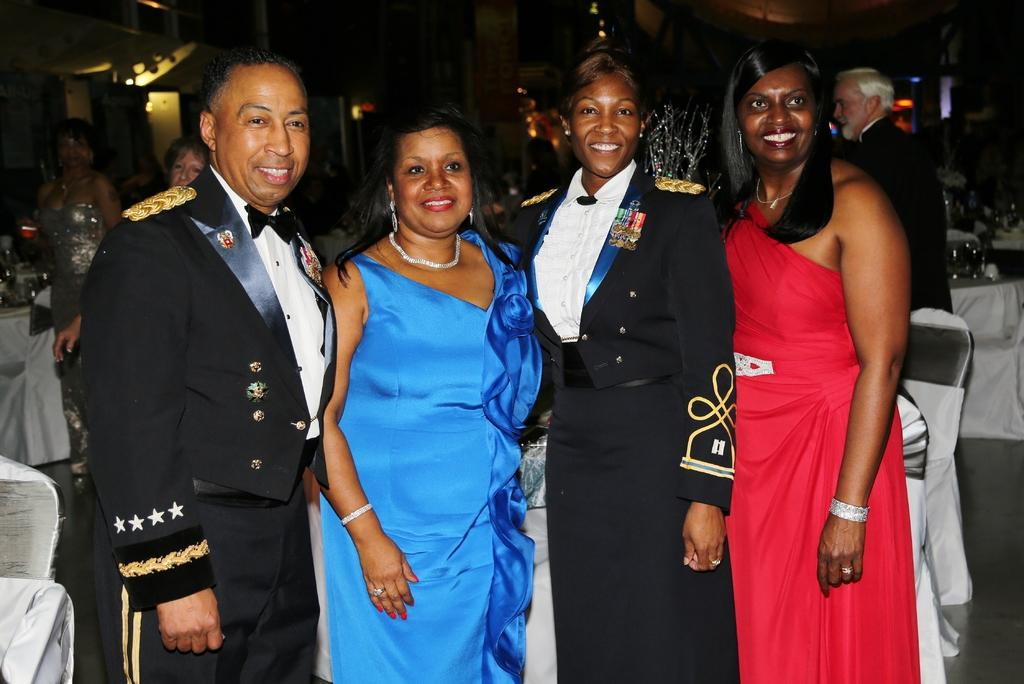How many people are present in the image? There are three women and a man in the image, making a total of four people. What are the people in the image doing? The people are standing and smiling in the image. What can be seen in the background of the image? There are tables, chairs, and lights visible in the background of the image. Are there any other people visible in the background? Yes, there are other persons visible in the background of the image. What is the texture of the ground in the image? There is no ground visible in the image; it appears to be an indoor setting with tables, chairs, and lights. Can you describe the brain activity of the people in the image? There is no information about the brain activity of the people in the image, as we can only observe their physical actions and expressions. 